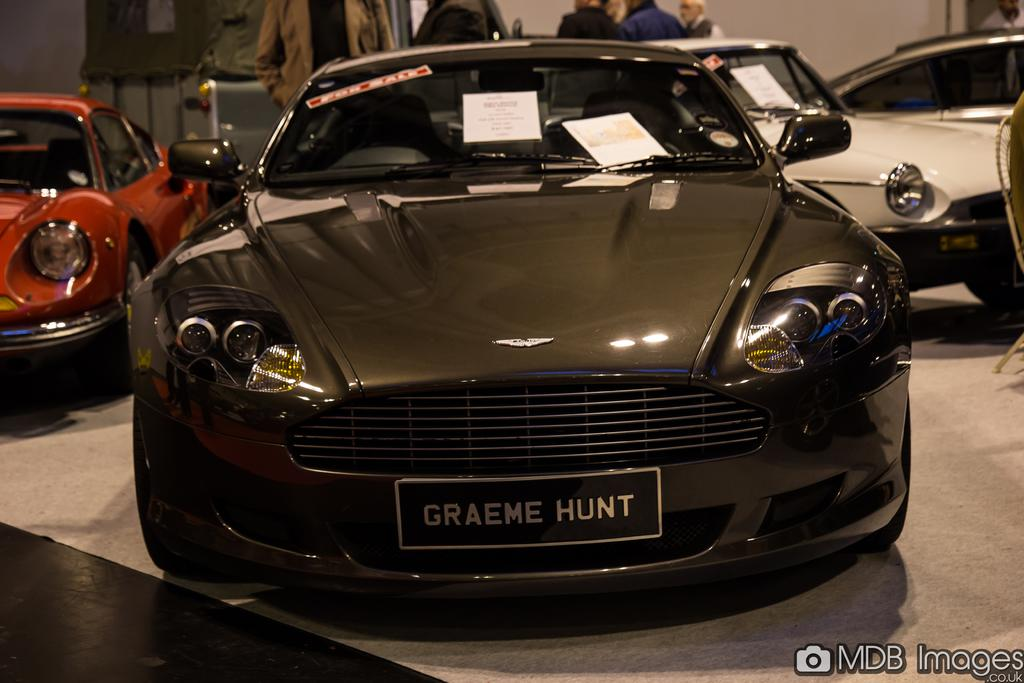What is the main subject in the center of the image? There is a car in the center of the image. What else can be seen in the background area? There are people and cars in the background area. Is there any text present in the image? Yes, there is text at the bottom side of the image. What type of loaf is being used to prop up the car in the image? There is no loaf present in the image, and the car is not being propped up by any object. 